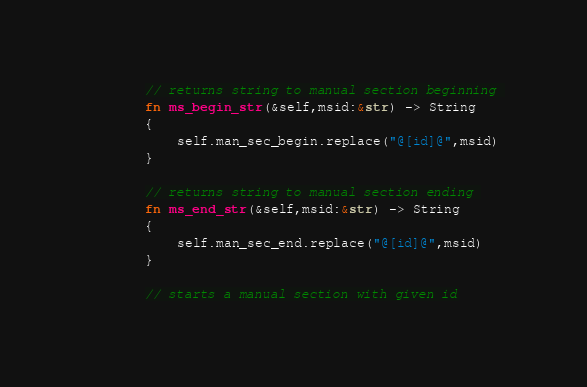Convert code to text. <code><loc_0><loc_0><loc_500><loc_500><_Rust_>        // returns string to manual section beginning 
        fn ms_begin_str(&self,msid:&str) -> String
        {
            self.man_sec_begin.replace("@[id]@",msid)
        }

        // returns string to manual section ending 
        fn ms_end_str(&self,msid:&str) -> String
        {
            self.man_sec_end.replace("@[id]@",msid)
        }

        // starts a manual section with given id</code> 